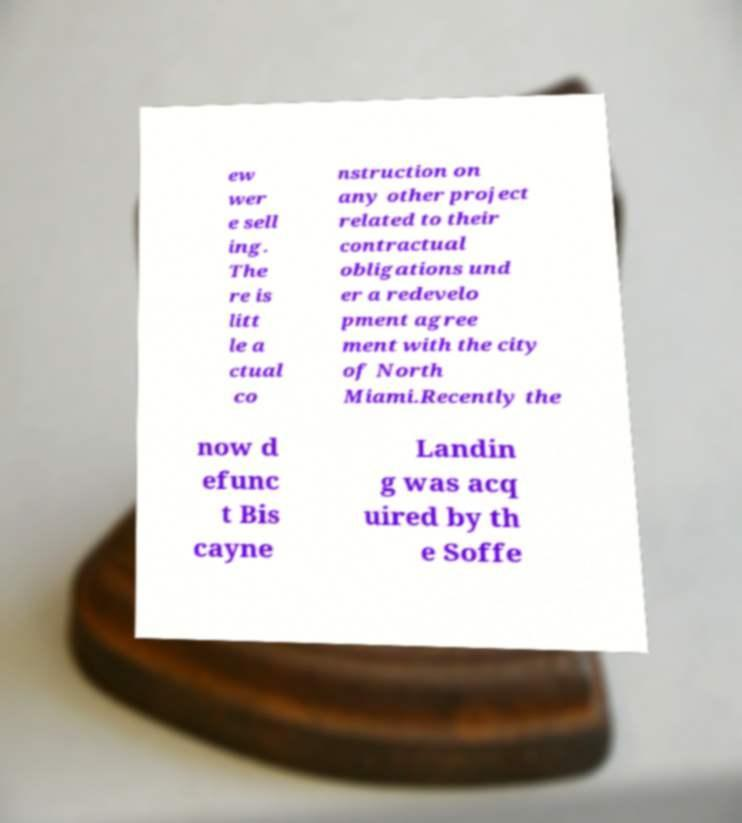Could you assist in decoding the text presented in this image and type it out clearly? ew wer e sell ing. The re is litt le a ctual co nstruction on any other project related to their contractual obligations und er a redevelo pment agree ment with the city of North Miami.Recently the now d efunc t Bis cayne Landin g was acq uired by th e Soffe 